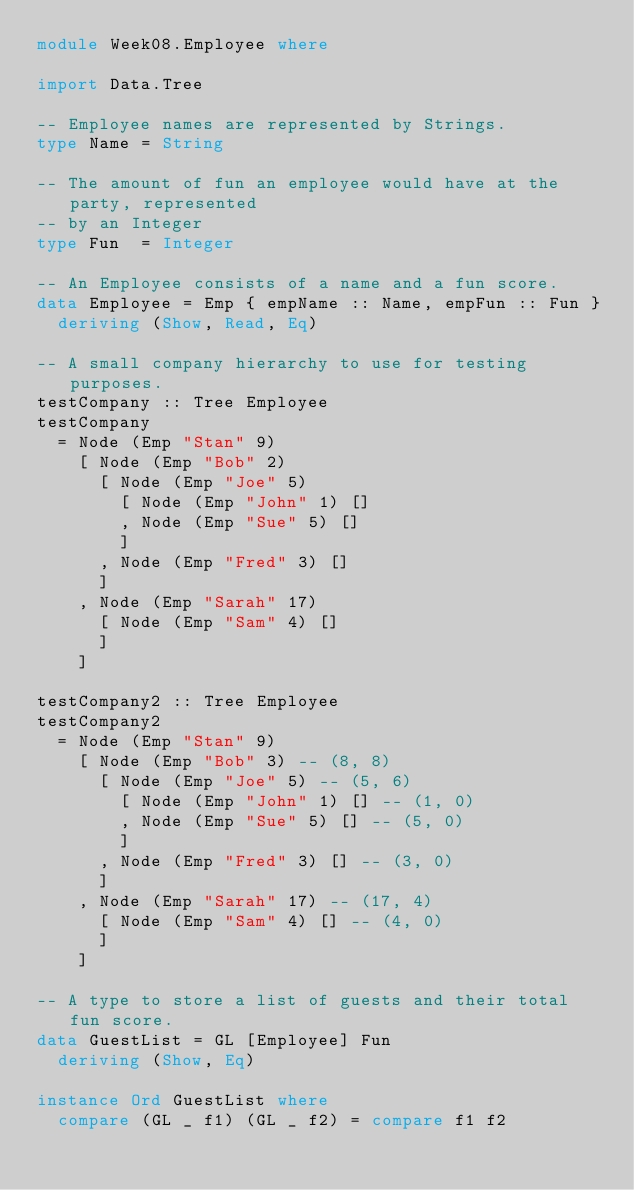Convert code to text. <code><loc_0><loc_0><loc_500><loc_500><_Haskell_>module Week08.Employee where

import Data.Tree

-- Employee names are represented by Strings.
type Name = String

-- The amount of fun an employee would have at the party, represented
-- by an Integer
type Fun  = Integer

-- An Employee consists of a name and a fun score.
data Employee = Emp { empName :: Name, empFun :: Fun }
  deriving (Show, Read, Eq)

-- A small company hierarchy to use for testing purposes.
testCompany :: Tree Employee
testCompany
  = Node (Emp "Stan" 9)
    [ Node (Emp "Bob" 2)
      [ Node (Emp "Joe" 5)
        [ Node (Emp "John" 1) []
        , Node (Emp "Sue" 5) []
        ]
      , Node (Emp "Fred" 3) []
      ]
    , Node (Emp "Sarah" 17)
      [ Node (Emp "Sam" 4) []
      ]
    ]

testCompany2 :: Tree Employee
testCompany2
  = Node (Emp "Stan" 9)
    [ Node (Emp "Bob" 3) -- (8, 8)
      [ Node (Emp "Joe" 5) -- (5, 6)
        [ Node (Emp "John" 1) [] -- (1, 0)
        , Node (Emp "Sue" 5) [] -- (5, 0)
        ]
      , Node (Emp "Fred" 3) [] -- (3, 0)
      ]
    , Node (Emp "Sarah" 17) -- (17, 4)
      [ Node (Emp "Sam" 4) [] -- (4, 0)
      ]
    ]

-- A type to store a list of guests and their total fun score.
data GuestList = GL [Employee] Fun
  deriving (Show, Eq)

instance Ord GuestList where
  compare (GL _ f1) (GL _ f2) = compare f1 f2
</code> 